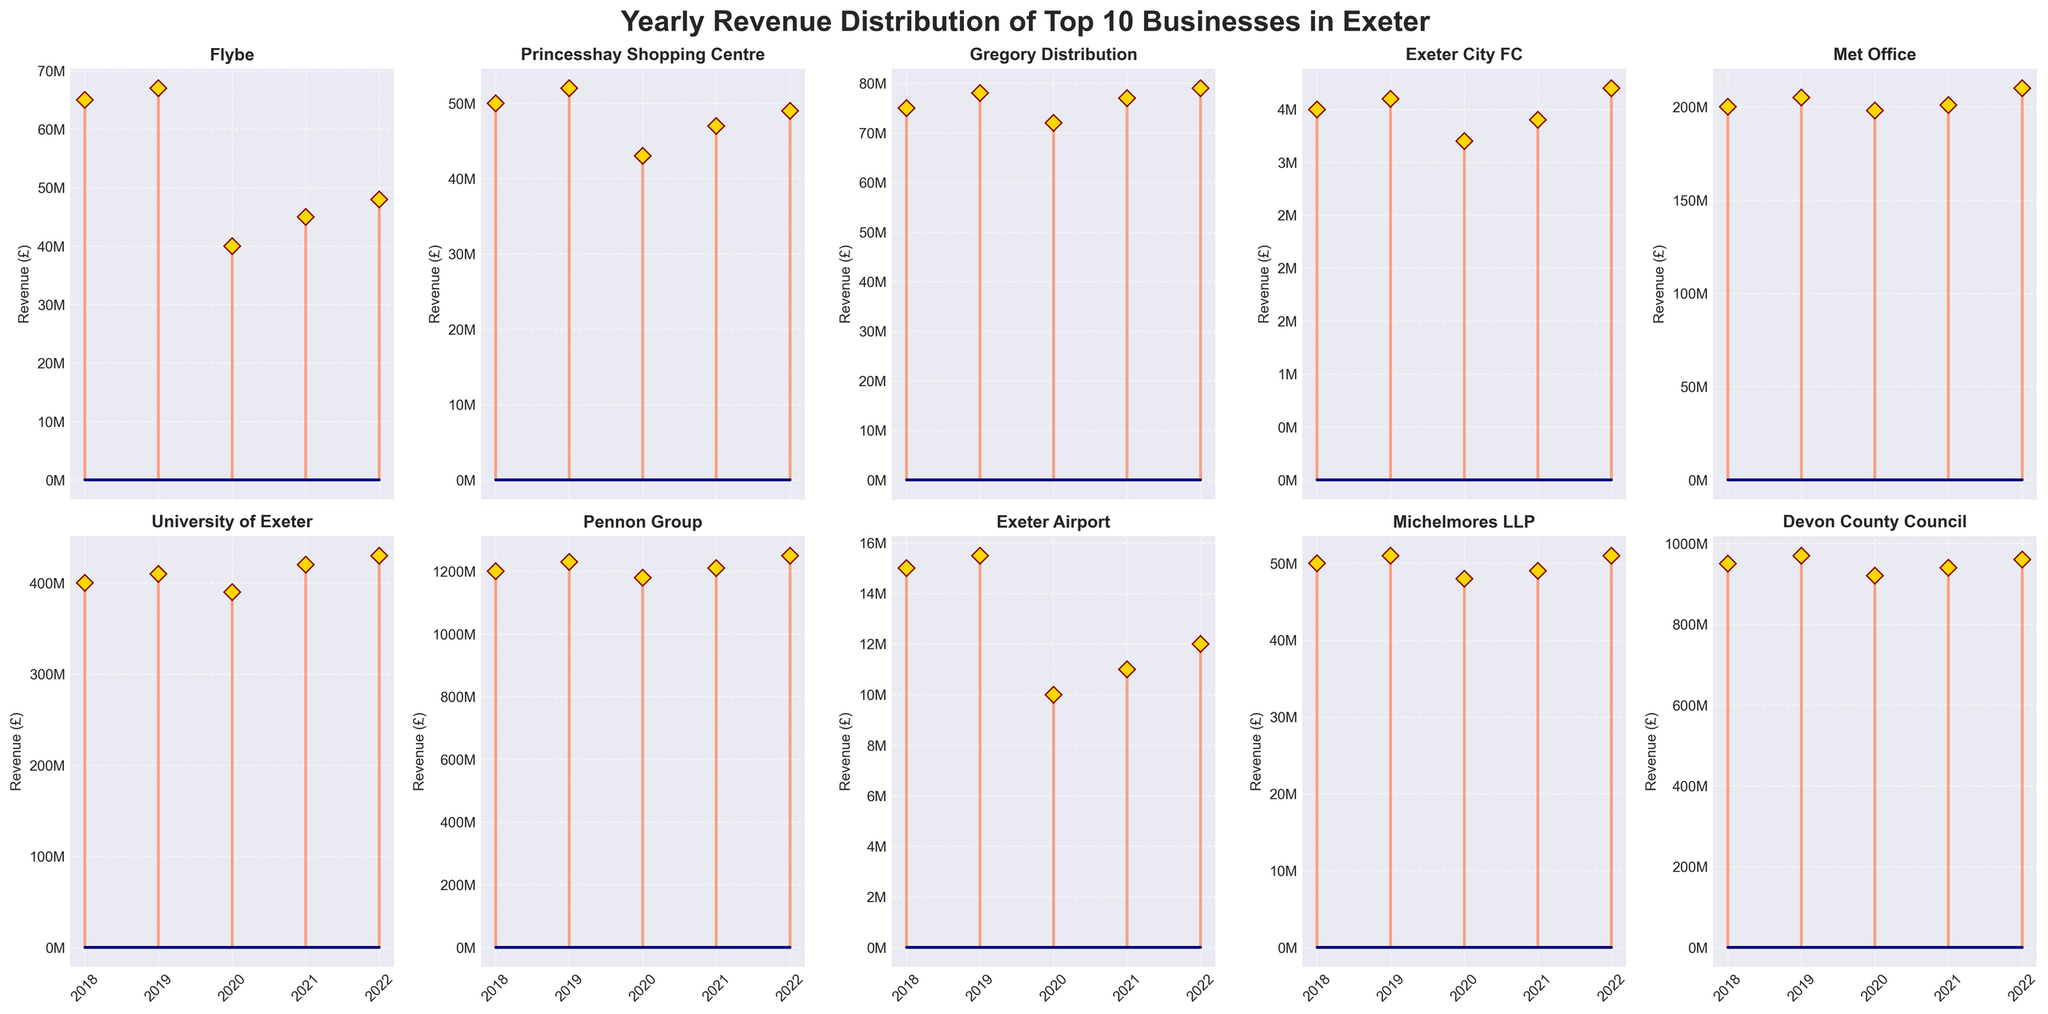What is the title of the figure? The title is usually displayed at the top of the figure, giving a summary of the chart's content. In this case, the title is indicated in the code's `fig.suptitle` line.
Answer: Yearly Revenue Distribution of Top 10 Businesses in Exeter How many subplots are there in the figure? Each subplot represents a business and there are a total of 10 businesses mentioned, which are arranged in a 2x5 grid.
Answer: 10 Which business had the highest revenue in 2022? Look at the stem plots for 2022, and compare the values shown for each business. The highest value in 2022 belongs to Pennon Group.
Answer: Pennon Group What is the revenue trend for Flybe from 2018 to 2022? Examine the stem plot for Flybe, noting whether the revenue increases or decreases over time. Flybe’s revenue decreases from 2018 to 2020, then slightly recovers each subsequent year.
Answer: Decreasing then slight recovery Which business shows a consistent increasing revenue trend from 2018 to 2022? Observe the stem plots for each business and identify the one where the revenue consistently increases across all years. University of Exeter shows consistent growth from 2018 to 2022.
Answer: University of Exeter What is the average revenue of Exeter City FC from 2018 to 2022? To find the average, sum the revenues for Exeter City FC from 2018 to 2022 and then divide by 5. The revenues are 3.5M, 3.6M, 3.2M, 3.4M, and 3.7M. The sum is 17.4M, and the average is 17.4M / 5.
Answer: 3.48M Which year did the Met Office have the lowest revenue? Review the stem plot for the Met Office and identify the year with the lowest revenue. The lowest revenue is in 2020.
Answer: 2020 Compare the revenue trends between Princesshay Shopping Centre and Michelmores LLP from 2018 to 2022. Examine the stem plots for both businesses and note the trend over the years. Both businesses have a similar trend where the revenue dips in 2020 and then recovers.
Answer: Similar trend with dip in 2020 How does the revenue of Gregory Distribution in 2022 compare to 2018? Find the revenues of Gregory Distribution for both years in the stem plot and compare them. The revenue increases from 75M in 2018 to 79M in 2022.
Answer: Increased What can you infer from the stemline colors and marker styles used in the plots? The colors and markers help differentiate data points and make the chart visually appealing. The stems are in coral, markers have a gold face with dark red edges, aiding quick visual analysis.
Answer: Distinct differentiation, visual appeal 